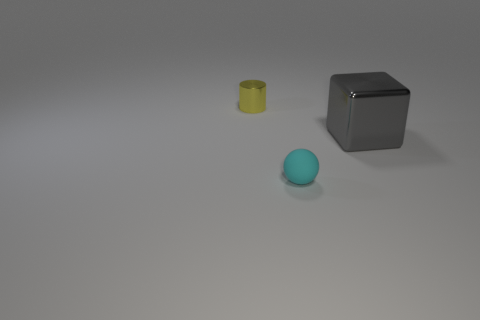Subtract all balls. How many objects are left? 2 Add 1 big green cylinders. How many big green cylinders exist? 1 Add 2 brown metallic spheres. How many objects exist? 5 Subtract 0 green balls. How many objects are left? 3 Subtract 1 cylinders. How many cylinders are left? 0 Subtract all yellow cubes. Subtract all brown cylinders. How many cubes are left? 1 Subtract all green blocks. How many brown spheres are left? 0 Subtract all big brown balls. Subtract all cyan spheres. How many objects are left? 2 Add 3 tiny shiny things. How many tiny shiny things are left? 4 